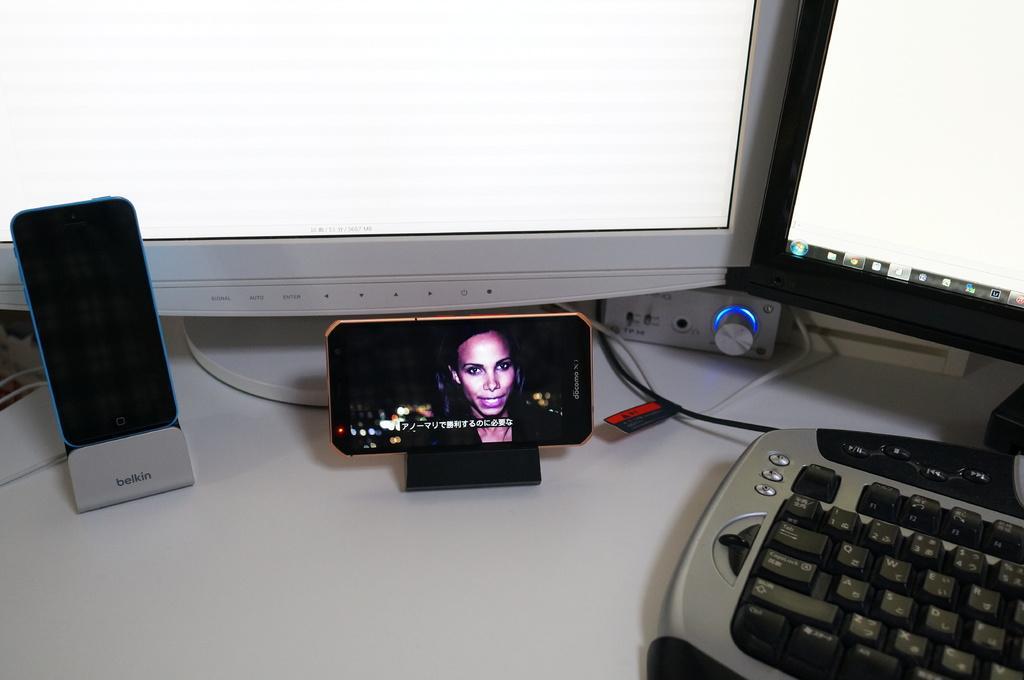Describe this image in one or two sentences. In this picture I can see mobiles on the mobile holders, there are monitors, keyboard, cables and there is an object on the table. 